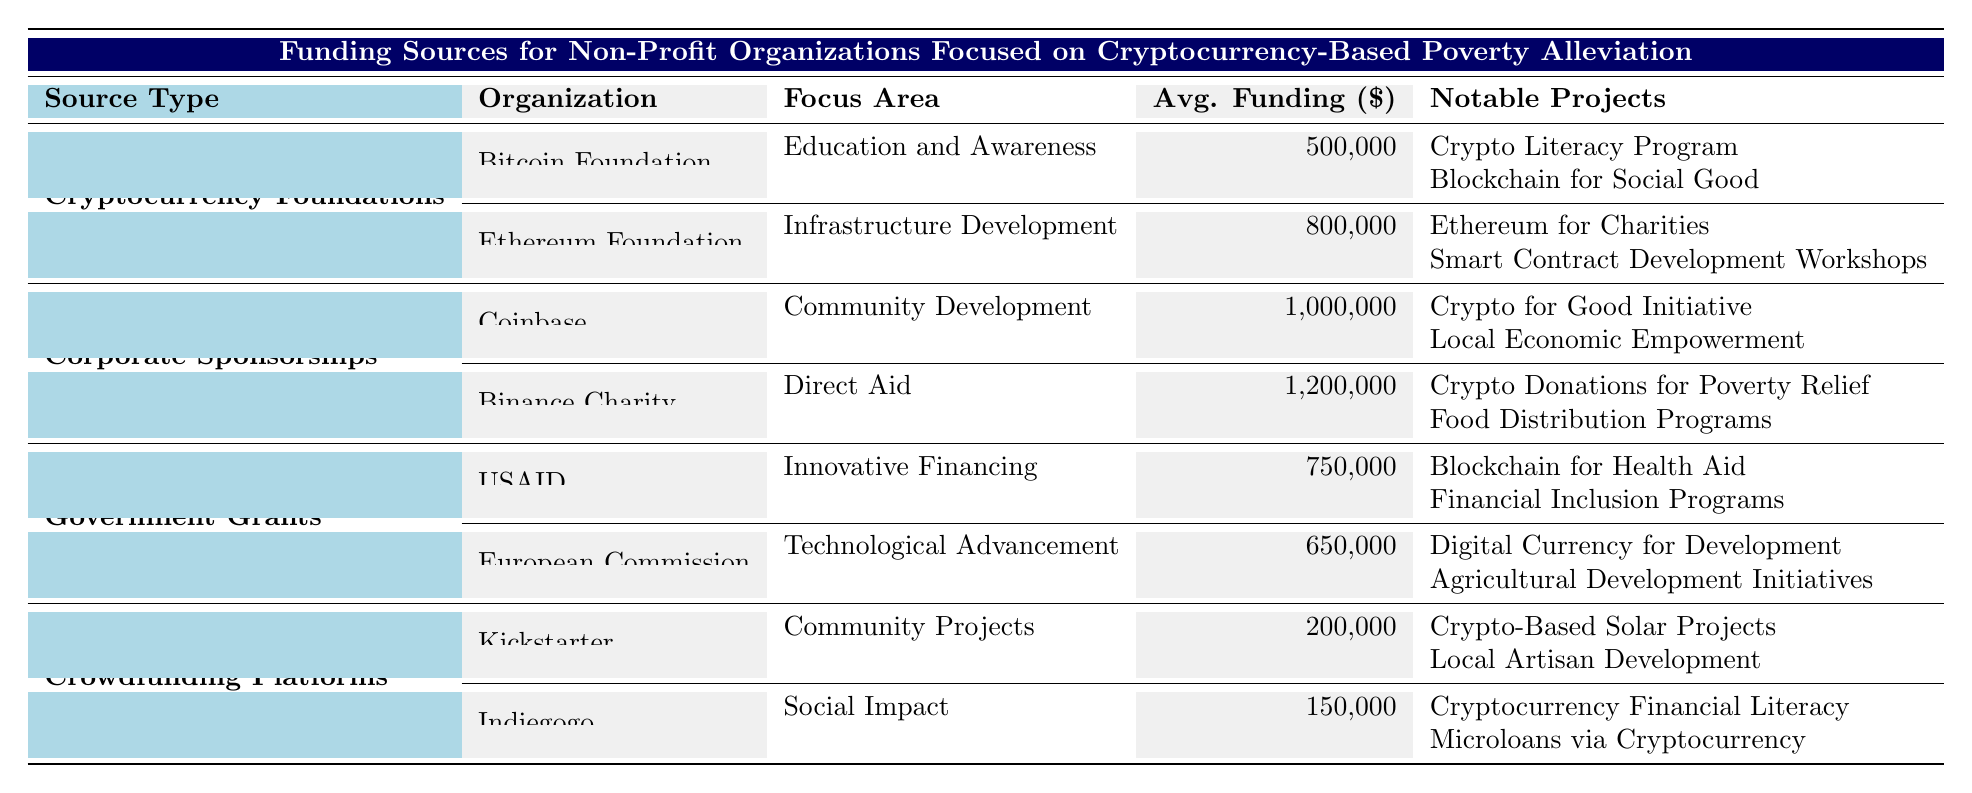What is the average funding amount from the Binance Charity? The table states that Binance Charity has an average funding amount of $1,200,000. This value is explicitly listed under the "Avg. Funding ($)" column for that organization.
Answer: 1,200,000 What focus area is associated with the Ethereum Foundation? The table indicates that the Ethereum Foundation's focus area is "Infrastructure Development." This information can be found in the "Focus Area" column corresponding to the Ethereum Foundation entry.
Answer: Infrastructure Development How many notable projects does the Coinbase organization have? Coinbase has two notable projects listed: "Crypto for Good Initiative" and "Local Economic Empowerment." This can be deduced from the "Notable Projects" column which shows these entries listed under Coinbase.
Answer: 2 Which source type has the highest average funding amount? By reviewing the average funding amounts from all organizations, it is evident that "Corporate Sponsorships" has the highest average funding amount, with Binance Charity at $1,200,000. This is the highest value found in the "Avg. Funding ($)" column across all funding sources.
Answer: Corporate Sponsorships Is the funding from the Bitcoin Foundation focused on "Direct Aid"? The focus area for the Bitcoin Foundation is "Education and Awareness." Since this is not "Direct Aid," the answer to the question is no. The information can be found in the "Focus Area" column for the Bitcoin Foundation.
Answer: No What is the combined average funding amount from all Crowdfunding Platforms listed? The average funding amounts for Kickstarter is $200,000 and for Indiegogo it is $150,000. The combined total is $200,000 + $150,000 = $350,000. To find the average funding amount for the two platforms, divide by 2, thus $350,000 / 2 = $175,000.
Answer: 175,000 Which organization has the focus area "Financial Inclusion Programs"? The organization listed with the focus area "Financial Inclusion Programs" is USAID under Government Grants. This can be verified by cross-referencing the "Focus Area" column with the corresponding organization listed.
Answer: USAID Is the average funding from the European Commission greater than $700,000? The average funding amount from the European Commission is $650,000, which is less than $700,000. This can be confirmed by checking the "Avg. Funding ($)" column for that organization.
Answer: No How many funding sources have an average funding amount over $1,000,000? There are two organizations with average funding over $1,000,000: Coinbase ($1,000,000) and Binance Charity ($1,200,000). Hence, the total count of funding sources in this category is 2.
Answer: 2 